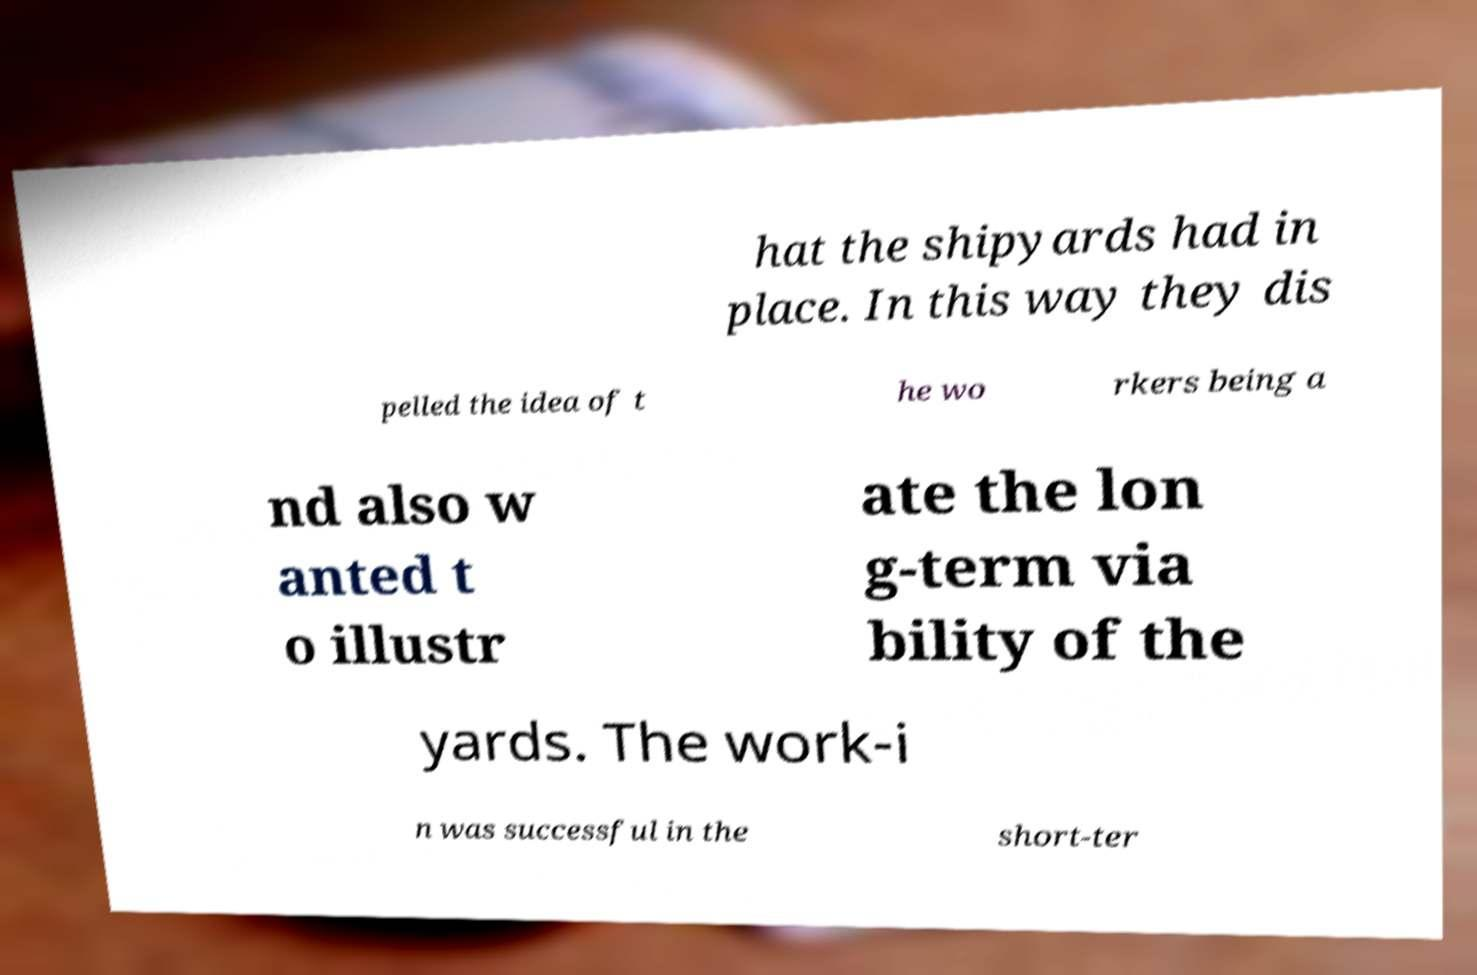What messages or text are displayed in this image? I need them in a readable, typed format. hat the shipyards had in place. In this way they dis pelled the idea of t he wo rkers being a nd also w anted t o illustr ate the lon g-term via bility of the yards. The work-i n was successful in the short-ter 